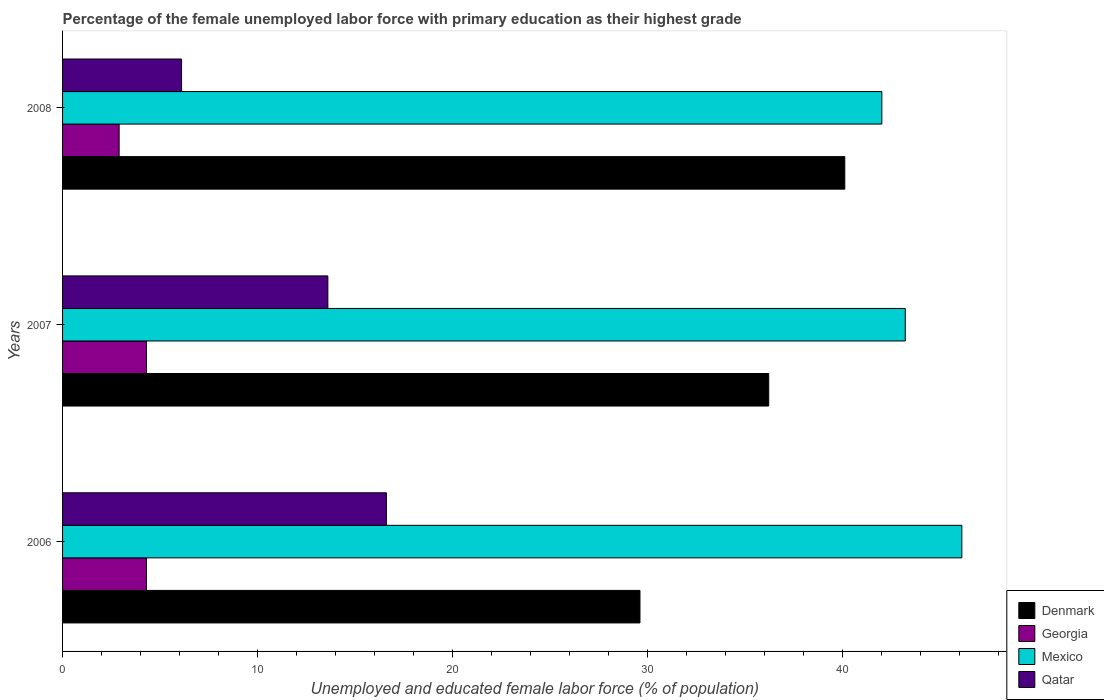How many different coloured bars are there?
Provide a short and direct response. 4. How many groups of bars are there?
Give a very brief answer. 3. Are the number of bars per tick equal to the number of legend labels?
Provide a succinct answer. Yes. How many bars are there on the 1st tick from the bottom?
Your response must be concise. 4. What is the label of the 3rd group of bars from the top?
Your response must be concise. 2006. In how many cases, is the number of bars for a given year not equal to the number of legend labels?
Give a very brief answer. 0. What is the percentage of the unemployed female labor force with primary education in Mexico in 2007?
Your response must be concise. 43.2. Across all years, what is the maximum percentage of the unemployed female labor force with primary education in Denmark?
Give a very brief answer. 40.1. Across all years, what is the minimum percentage of the unemployed female labor force with primary education in Mexico?
Ensure brevity in your answer.  42. In which year was the percentage of the unemployed female labor force with primary education in Denmark maximum?
Provide a short and direct response. 2008. In which year was the percentage of the unemployed female labor force with primary education in Georgia minimum?
Provide a succinct answer. 2008. What is the total percentage of the unemployed female labor force with primary education in Qatar in the graph?
Provide a short and direct response. 36.3. What is the difference between the percentage of the unemployed female labor force with primary education in Georgia in 2007 and that in 2008?
Offer a very short reply. 1.4. What is the difference between the percentage of the unemployed female labor force with primary education in Qatar in 2008 and the percentage of the unemployed female labor force with primary education in Georgia in 2007?
Your answer should be very brief. 1.8. What is the average percentage of the unemployed female labor force with primary education in Mexico per year?
Keep it short and to the point. 43.77. In the year 2006, what is the difference between the percentage of the unemployed female labor force with primary education in Mexico and percentage of the unemployed female labor force with primary education in Qatar?
Offer a very short reply. 29.5. What is the ratio of the percentage of the unemployed female labor force with primary education in Georgia in 2006 to that in 2008?
Keep it short and to the point. 1.48. Is the percentage of the unemployed female labor force with primary education in Georgia in 2006 less than that in 2007?
Make the answer very short. No. Is the difference between the percentage of the unemployed female labor force with primary education in Mexico in 2007 and 2008 greater than the difference between the percentage of the unemployed female labor force with primary education in Qatar in 2007 and 2008?
Provide a short and direct response. No. What is the difference between the highest and the second highest percentage of the unemployed female labor force with primary education in Denmark?
Give a very brief answer. 3.9. What is the difference between the highest and the lowest percentage of the unemployed female labor force with primary education in Qatar?
Offer a very short reply. 10.5. In how many years, is the percentage of the unemployed female labor force with primary education in Denmark greater than the average percentage of the unemployed female labor force with primary education in Denmark taken over all years?
Provide a succinct answer. 2. Is it the case that in every year, the sum of the percentage of the unemployed female labor force with primary education in Denmark and percentage of the unemployed female labor force with primary education in Qatar is greater than the sum of percentage of the unemployed female labor force with primary education in Mexico and percentage of the unemployed female labor force with primary education in Georgia?
Keep it short and to the point. Yes. What does the 1st bar from the top in 2008 represents?
Make the answer very short. Qatar. Are all the bars in the graph horizontal?
Provide a short and direct response. Yes. Are the values on the major ticks of X-axis written in scientific E-notation?
Keep it short and to the point. No. Does the graph contain grids?
Provide a succinct answer. No. How are the legend labels stacked?
Your response must be concise. Vertical. What is the title of the graph?
Make the answer very short. Percentage of the female unemployed labor force with primary education as their highest grade. What is the label or title of the X-axis?
Offer a very short reply. Unemployed and educated female labor force (% of population). What is the label or title of the Y-axis?
Offer a very short reply. Years. What is the Unemployed and educated female labor force (% of population) of Denmark in 2006?
Provide a succinct answer. 29.6. What is the Unemployed and educated female labor force (% of population) of Georgia in 2006?
Provide a succinct answer. 4.3. What is the Unemployed and educated female labor force (% of population) of Mexico in 2006?
Offer a very short reply. 46.1. What is the Unemployed and educated female labor force (% of population) in Qatar in 2006?
Offer a terse response. 16.6. What is the Unemployed and educated female labor force (% of population) in Denmark in 2007?
Your response must be concise. 36.2. What is the Unemployed and educated female labor force (% of population) of Georgia in 2007?
Your answer should be very brief. 4.3. What is the Unemployed and educated female labor force (% of population) in Mexico in 2007?
Make the answer very short. 43.2. What is the Unemployed and educated female labor force (% of population) of Qatar in 2007?
Your response must be concise. 13.6. What is the Unemployed and educated female labor force (% of population) of Denmark in 2008?
Make the answer very short. 40.1. What is the Unemployed and educated female labor force (% of population) of Georgia in 2008?
Make the answer very short. 2.9. What is the Unemployed and educated female labor force (% of population) in Mexico in 2008?
Keep it short and to the point. 42. What is the Unemployed and educated female labor force (% of population) in Qatar in 2008?
Offer a very short reply. 6.1. Across all years, what is the maximum Unemployed and educated female labor force (% of population) in Denmark?
Provide a succinct answer. 40.1. Across all years, what is the maximum Unemployed and educated female labor force (% of population) in Georgia?
Your answer should be compact. 4.3. Across all years, what is the maximum Unemployed and educated female labor force (% of population) of Mexico?
Give a very brief answer. 46.1. Across all years, what is the maximum Unemployed and educated female labor force (% of population) in Qatar?
Provide a succinct answer. 16.6. Across all years, what is the minimum Unemployed and educated female labor force (% of population) in Denmark?
Your answer should be very brief. 29.6. Across all years, what is the minimum Unemployed and educated female labor force (% of population) in Georgia?
Your answer should be very brief. 2.9. Across all years, what is the minimum Unemployed and educated female labor force (% of population) of Qatar?
Ensure brevity in your answer.  6.1. What is the total Unemployed and educated female labor force (% of population) of Denmark in the graph?
Give a very brief answer. 105.9. What is the total Unemployed and educated female labor force (% of population) in Georgia in the graph?
Ensure brevity in your answer.  11.5. What is the total Unemployed and educated female labor force (% of population) in Mexico in the graph?
Your response must be concise. 131.3. What is the total Unemployed and educated female labor force (% of population) in Qatar in the graph?
Ensure brevity in your answer.  36.3. What is the difference between the Unemployed and educated female labor force (% of population) in Georgia in 2006 and that in 2007?
Make the answer very short. 0. What is the difference between the Unemployed and educated female labor force (% of population) of Mexico in 2006 and that in 2007?
Your response must be concise. 2.9. What is the difference between the Unemployed and educated female labor force (% of population) in Denmark in 2006 and that in 2008?
Keep it short and to the point. -10.5. What is the difference between the Unemployed and educated female labor force (% of population) in Georgia in 2006 and that in 2008?
Your answer should be compact. 1.4. What is the difference between the Unemployed and educated female labor force (% of population) in Qatar in 2006 and that in 2008?
Provide a succinct answer. 10.5. What is the difference between the Unemployed and educated female labor force (% of population) of Denmark in 2007 and that in 2008?
Make the answer very short. -3.9. What is the difference between the Unemployed and educated female labor force (% of population) in Georgia in 2007 and that in 2008?
Offer a very short reply. 1.4. What is the difference between the Unemployed and educated female labor force (% of population) in Mexico in 2007 and that in 2008?
Give a very brief answer. 1.2. What is the difference between the Unemployed and educated female labor force (% of population) in Qatar in 2007 and that in 2008?
Your response must be concise. 7.5. What is the difference between the Unemployed and educated female labor force (% of population) of Denmark in 2006 and the Unemployed and educated female labor force (% of population) of Georgia in 2007?
Give a very brief answer. 25.3. What is the difference between the Unemployed and educated female labor force (% of population) of Denmark in 2006 and the Unemployed and educated female labor force (% of population) of Qatar in 2007?
Provide a succinct answer. 16. What is the difference between the Unemployed and educated female labor force (% of population) in Georgia in 2006 and the Unemployed and educated female labor force (% of population) in Mexico in 2007?
Offer a terse response. -38.9. What is the difference between the Unemployed and educated female labor force (% of population) of Georgia in 2006 and the Unemployed and educated female labor force (% of population) of Qatar in 2007?
Keep it short and to the point. -9.3. What is the difference between the Unemployed and educated female labor force (% of population) of Mexico in 2006 and the Unemployed and educated female labor force (% of population) of Qatar in 2007?
Keep it short and to the point. 32.5. What is the difference between the Unemployed and educated female labor force (% of population) of Denmark in 2006 and the Unemployed and educated female labor force (% of population) of Georgia in 2008?
Offer a terse response. 26.7. What is the difference between the Unemployed and educated female labor force (% of population) in Georgia in 2006 and the Unemployed and educated female labor force (% of population) in Mexico in 2008?
Offer a very short reply. -37.7. What is the difference between the Unemployed and educated female labor force (% of population) of Georgia in 2006 and the Unemployed and educated female labor force (% of population) of Qatar in 2008?
Ensure brevity in your answer.  -1.8. What is the difference between the Unemployed and educated female labor force (% of population) of Mexico in 2006 and the Unemployed and educated female labor force (% of population) of Qatar in 2008?
Provide a short and direct response. 40. What is the difference between the Unemployed and educated female labor force (% of population) in Denmark in 2007 and the Unemployed and educated female labor force (% of population) in Georgia in 2008?
Provide a succinct answer. 33.3. What is the difference between the Unemployed and educated female labor force (% of population) of Denmark in 2007 and the Unemployed and educated female labor force (% of population) of Qatar in 2008?
Ensure brevity in your answer.  30.1. What is the difference between the Unemployed and educated female labor force (% of population) in Georgia in 2007 and the Unemployed and educated female labor force (% of population) in Mexico in 2008?
Make the answer very short. -37.7. What is the difference between the Unemployed and educated female labor force (% of population) in Mexico in 2007 and the Unemployed and educated female labor force (% of population) in Qatar in 2008?
Offer a terse response. 37.1. What is the average Unemployed and educated female labor force (% of population) of Denmark per year?
Provide a short and direct response. 35.3. What is the average Unemployed and educated female labor force (% of population) of Georgia per year?
Your answer should be very brief. 3.83. What is the average Unemployed and educated female labor force (% of population) in Mexico per year?
Offer a very short reply. 43.77. In the year 2006, what is the difference between the Unemployed and educated female labor force (% of population) in Denmark and Unemployed and educated female labor force (% of population) in Georgia?
Keep it short and to the point. 25.3. In the year 2006, what is the difference between the Unemployed and educated female labor force (% of population) in Denmark and Unemployed and educated female labor force (% of population) in Mexico?
Offer a very short reply. -16.5. In the year 2006, what is the difference between the Unemployed and educated female labor force (% of population) in Denmark and Unemployed and educated female labor force (% of population) in Qatar?
Make the answer very short. 13. In the year 2006, what is the difference between the Unemployed and educated female labor force (% of population) of Georgia and Unemployed and educated female labor force (% of population) of Mexico?
Your answer should be compact. -41.8. In the year 2006, what is the difference between the Unemployed and educated female labor force (% of population) of Mexico and Unemployed and educated female labor force (% of population) of Qatar?
Your answer should be very brief. 29.5. In the year 2007, what is the difference between the Unemployed and educated female labor force (% of population) in Denmark and Unemployed and educated female labor force (% of population) in Georgia?
Your answer should be compact. 31.9. In the year 2007, what is the difference between the Unemployed and educated female labor force (% of population) of Denmark and Unemployed and educated female labor force (% of population) of Mexico?
Provide a short and direct response. -7. In the year 2007, what is the difference between the Unemployed and educated female labor force (% of population) of Denmark and Unemployed and educated female labor force (% of population) of Qatar?
Make the answer very short. 22.6. In the year 2007, what is the difference between the Unemployed and educated female labor force (% of population) of Georgia and Unemployed and educated female labor force (% of population) of Mexico?
Your response must be concise. -38.9. In the year 2007, what is the difference between the Unemployed and educated female labor force (% of population) of Mexico and Unemployed and educated female labor force (% of population) of Qatar?
Provide a short and direct response. 29.6. In the year 2008, what is the difference between the Unemployed and educated female labor force (% of population) in Denmark and Unemployed and educated female labor force (% of population) in Georgia?
Provide a succinct answer. 37.2. In the year 2008, what is the difference between the Unemployed and educated female labor force (% of population) in Georgia and Unemployed and educated female labor force (% of population) in Mexico?
Your answer should be very brief. -39.1. In the year 2008, what is the difference between the Unemployed and educated female labor force (% of population) in Mexico and Unemployed and educated female labor force (% of population) in Qatar?
Ensure brevity in your answer.  35.9. What is the ratio of the Unemployed and educated female labor force (% of population) in Denmark in 2006 to that in 2007?
Your response must be concise. 0.82. What is the ratio of the Unemployed and educated female labor force (% of population) of Mexico in 2006 to that in 2007?
Give a very brief answer. 1.07. What is the ratio of the Unemployed and educated female labor force (% of population) of Qatar in 2006 to that in 2007?
Provide a succinct answer. 1.22. What is the ratio of the Unemployed and educated female labor force (% of population) of Denmark in 2006 to that in 2008?
Provide a succinct answer. 0.74. What is the ratio of the Unemployed and educated female labor force (% of population) in Georgia in 2006 to that in 2008?
Provide a succinct answer. 1.48. What is the ratio of the Unemployed and educated female labor force (% of population) of Mexico in 2006 to that in 2008?
Your response must be concise. 1.1. What is the ratio of the Unemployed and educated female labor force (% of population) of Qatar in 2006 to that in 2008?
Give a very brief answer. 2.72. What is the ratio of the Unemployed and educated female labor force (% of population) of Denmark in 2007 to that in 2008?
Offer a terse response. 0.9. What is the ratio of the Unemployed and educated female labor force (% of population) in Georgia in 2007 to that in 2008?
Your answer should be very brief. 1.48. What is the ratio of the Unemployed and educated female labor force (% of population) of Mexico in 2007 to that in 2008?
Your answer should be very brief. 1.03. What is the ratio of the Unemployed and educated female labor force (% of population) of Qatar in 2007 to that in 2008?
Your response must be concise. 2.23. What is the difference between the highest and the second highest Unemployed and educated female labor force (% of population) in Mexico?
Your answer should be compact. 2.9. What is the difference between the highest and the lowest Unemployed and educated female labor force (% of population) in Georgia?
Ensure brevity in your answer.  1.4. What is the difference between the highest and the lowest Unemployed and educated female labor force (% of population) in Mexico?
Provide a succinct answer. 4.1. 